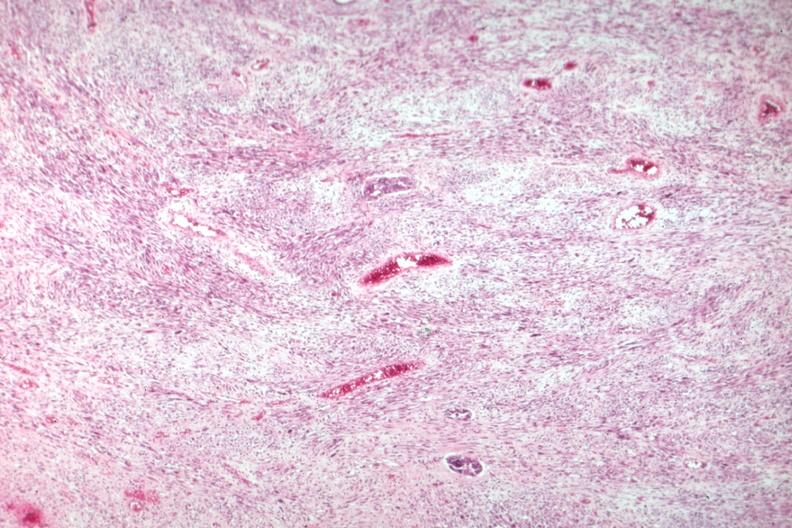what is present?
Answer the question using a single word or phrase. Uterus 